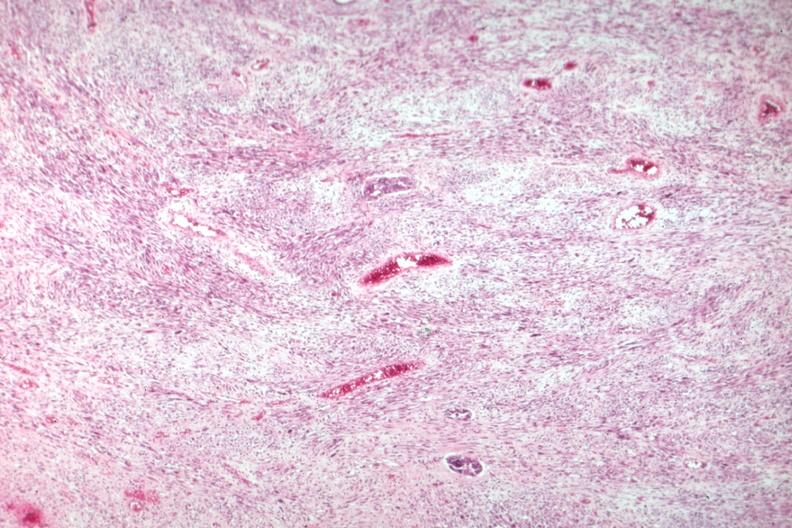what is present?
Answer the question using a single word or phrase. Uterus 